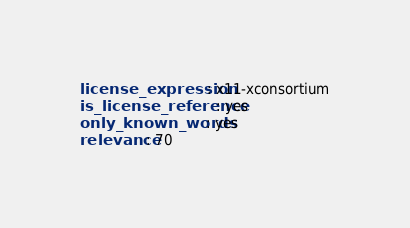<code> <loc_0><loc_0><loc_500><loc_500><_YAML_>license_expression: x11-xconsortium
is_license_reference: yes
only_known_words: yes
relevance: 70
</code> 